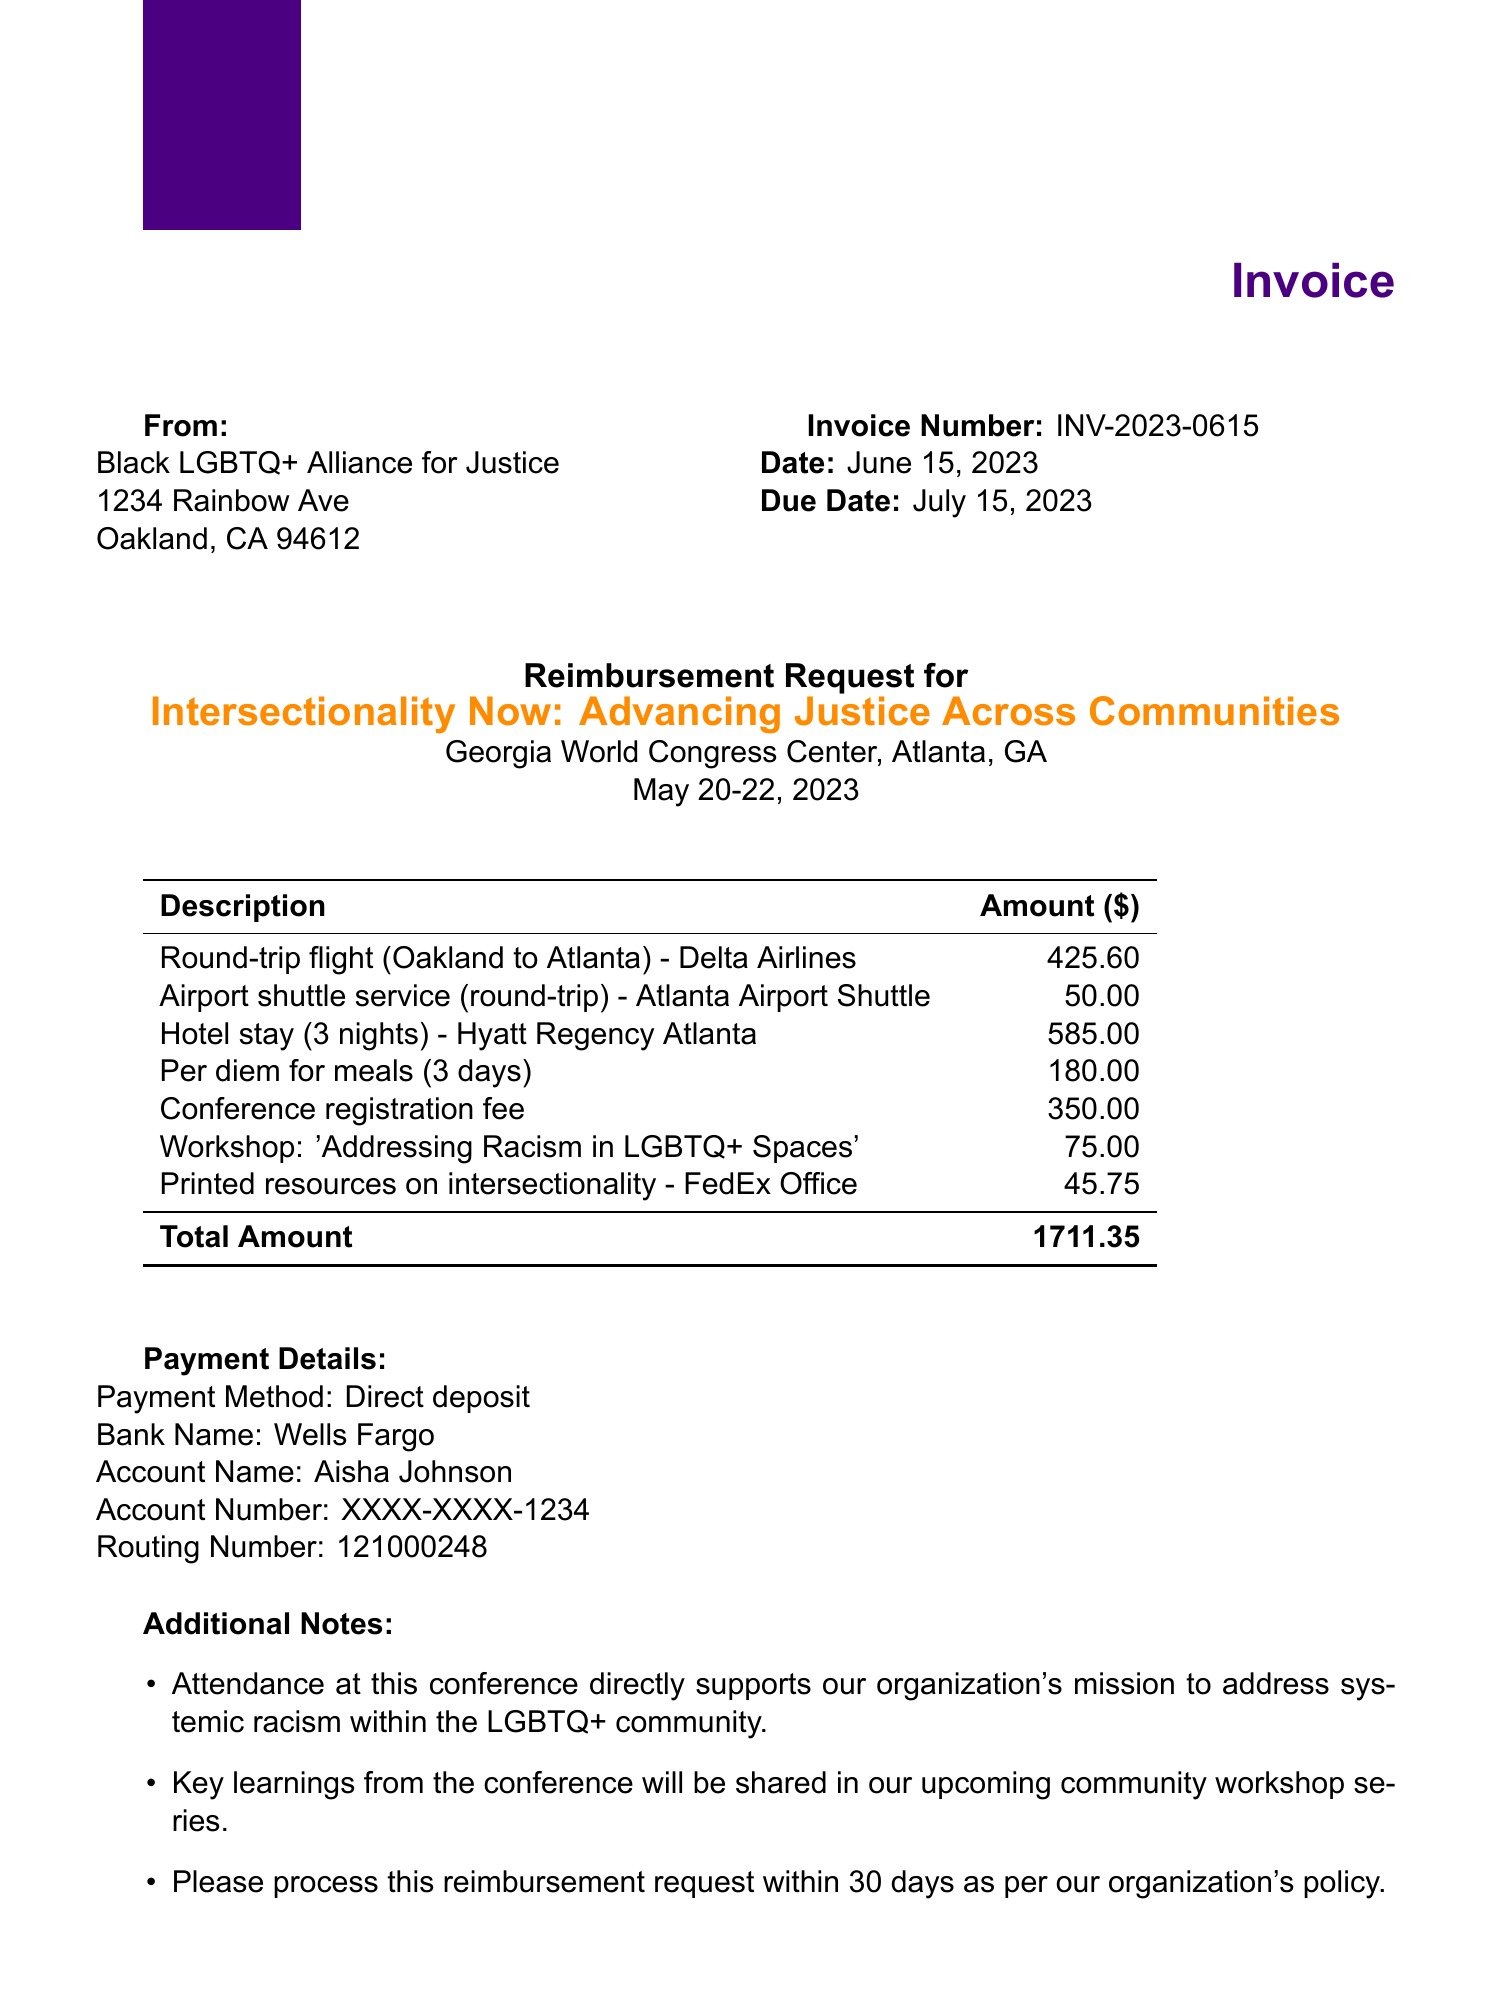What is the invoice number? The invoice number is listed at the top of the document, which serves as a unique identifier for this reimbursement request.
Answer: INV-2023-0615 What is the payee organization? The payee organization is specified to show the entity requesting reimbursement for travel expenses.
Answer: Black LGBTQ+ Alliance for Justice What are the total travel expenses? The total amount reflects the sum of all categories of travel expenses listed in the document.
Answer: 1711.35 What is the conference registration fee? The registration fee is a specific expense related to attending the conference mentioned in the document.
Answer: 350.00 Where was the conference held? The location of the conference provides context about where the expenses were incurred.
Answer: Atlanta, GA How many nights did the hotel stay cover? The duration of the hotel stay impacts the accommodation expenses recorded in the invoice.
Answer: 3 nights What is the payment method? The payment method informs how the reimbursement will be processed according to the document.
Answer: Direct deposit Name one resource provided at the conference. Identifying a specific workshop highlights the content of the conference attended, which relates to the payee's mission.
Answer: Addressing Racism in LGBTQ+ Spaces Why is attendance at this conference important? This explains the significance of the event in relation to the organization's mission as noted in the additional notes.
Answer: Address systemic racism within the LGBTQ+ community 